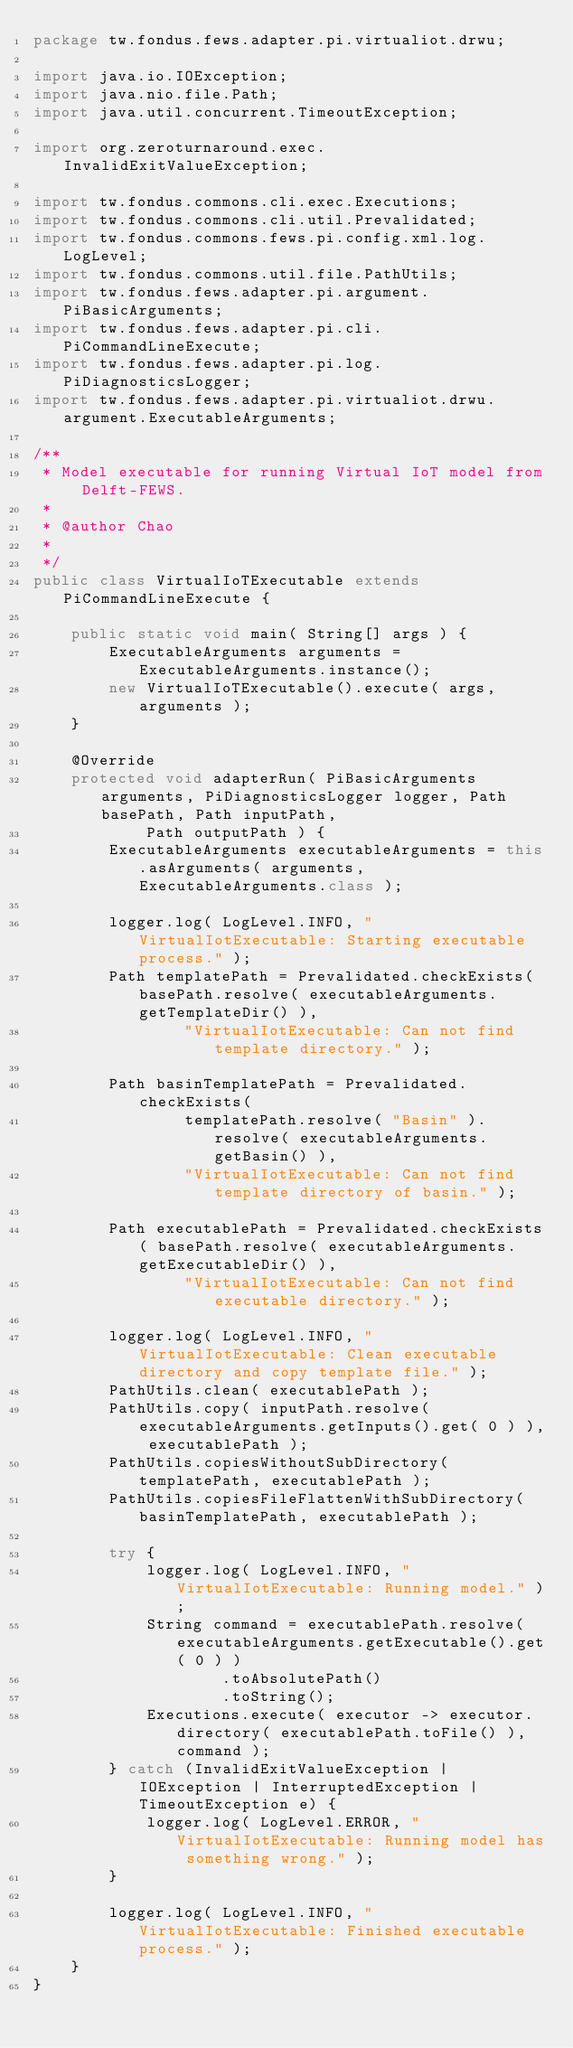Convert code to text. <code><loc_0><loc_0><loc_500><loc_500><_Java_>package tw.fondus.fews.adapter.pi.virtualiot.drwu;

import java.io.IOException;
import java.nio.file.Path;
import java.util.concurrent.TimeoutException;

import org.zeroturnaround.exec.InvalidExitValueException;

import tw.fondus.commons.cli.exec.Executions;
import tw.fondus.commons.cli.util.Prevalidated;
import tw.fondus.commons.fews.pi.config.xml.log.LogLevel;
import tw.fondus.commons.util.file.PathUtils;
import tw.fondus.fews.adapter.pi.argument.PiBasicArguments;
import tw.fondus.fews.adapter.pi.cli.PiCommandLineExecute;
import tw.fondus.fews.adapter.pi.log.PiDiagnosticsLogger;
import tw.fondus.fews.adapter.pi.virtualiot.drwu.argument.ExecutableArguments;

/**
 * Model executable for running Virtual IoT model from Delft-FEWS.
 * 
 * @author Chao
 *
 */
public class VirtualIoTExecutable extends PiCommandLineExecute {

	public static void main( String[] args ) {
		ExecutableArguments arguments = ExecutableArguments.instance();
		new VirtualIoTExecutable().execute( args, arguments );
	}

	@Override
	protected void adapterRun( PiBasicArguments arguments, PiDiagnosticsLogger logger, Path basePath, Path inputPath,
			Path outputPath ) {
		ExecutableArguments executableArguments = this.asArguments( arguments, ExecutableArguments.class );

		logger.log( LogLevel.INFO, "VirtualIotExecutable: Starting executable process." );
		Path templatePath = Prevalidated.checkExists( basePath.resolve( executableArguments.getTemplateDir() ),
				"VirtualIotExecutable: Can not find template directory." );

		Path basinTemplatePath = Prevalidated.checkExists(
				templatePath.resolve( "Basin" ).resolve( executableArguments.getBasin() ),
				"VirtualIotExecutable: Can not find template directory of basin." );

		Path executablePath = Prevalidated.checkExists( basePath.resolve( executableArguments.getExecutableDir() ),
				"VirtualIotExecutable: Can not find executable directory." );

		logger.log( LogLevel.INFO, "VirtualIotExecutable: Clean executable directory and copy template file." );
		PathUtils.clean( executablePath );
		PathUtils.copy( inputPath.resolve( executableArguments.getInputs().get( 0 ) ), executablePath );
		PathUtils.copiesWithoutSubDirectory( templatePath, executablePath );
		PathUtils.copiesFileFlattenWithSubDirectory( basinTemplatePath, executablePath );

		try {
			logger.log( LogLevel.INFO, "VirtualIotExecutable: Running model." );
			String command = executablePath.resolve( executableArguments.getExecutable().get( 0 ) )
					.toAbsolutePath()
					.toString();
			Executions.execute( executor -> executor.directory( executablePath.toFile() ), command );
		} catch (InvalidExitValueException | IOException | InterruptedException | TimeoutException e) {
			logger.log( LogLevel.ERROR, "VirtualIotExecutable: Running model has something wrong." );
		}
		
		logger.log( LogLevel.INFO, "VirtualIotExecutable: Finished executable process." );
	}
}
</code> 